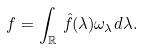Convert formula to latex. <formula><loc_0><loc_0><loc_500><loc_500>f = \int _ { \mathbb { R } } \, \hat { f } ( \lambda ) \omega _ { \lambda } d \lambda .</formula> 